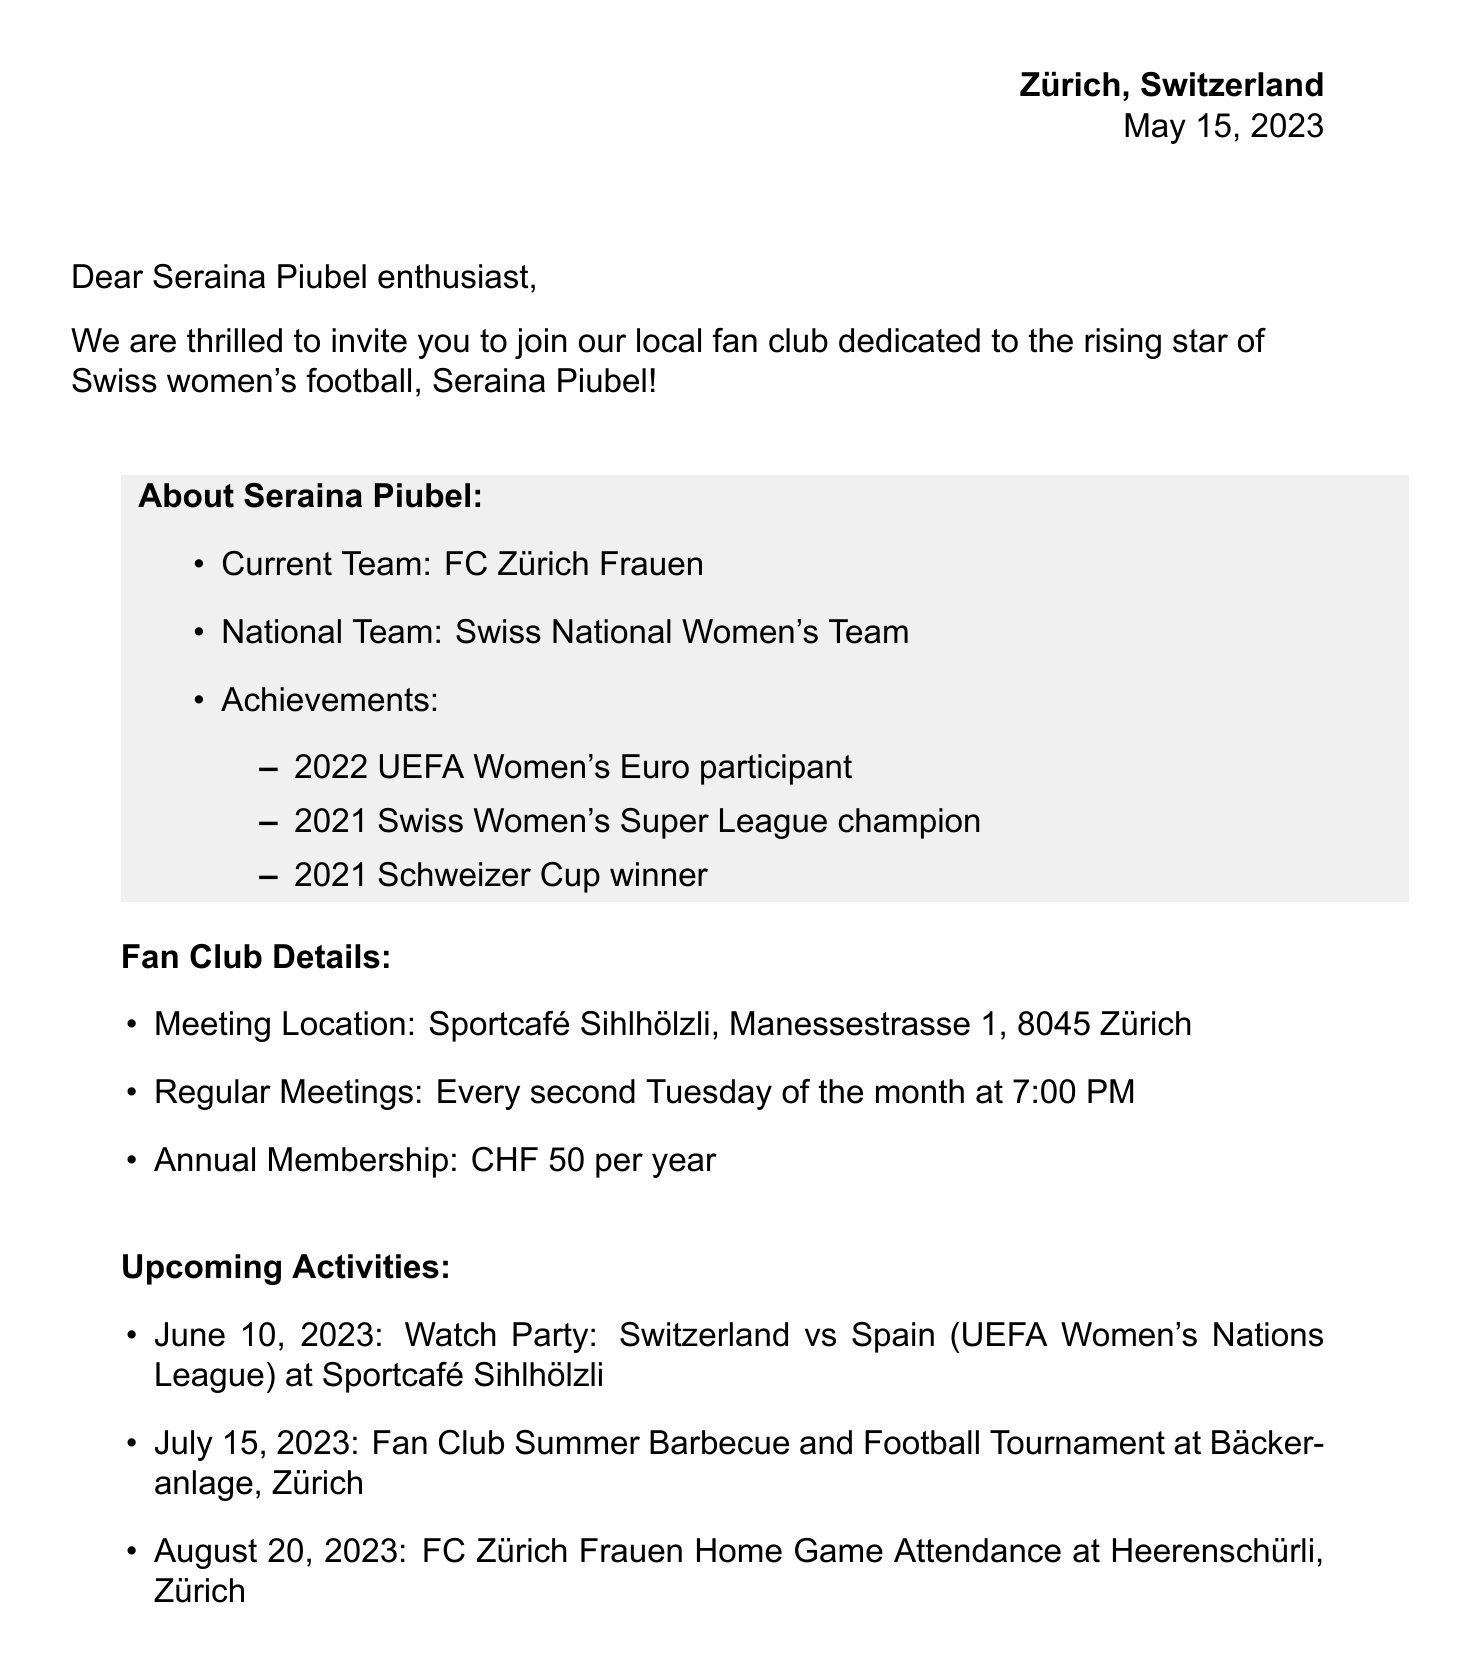What is the name of the fan club? The name of the fan club is explicitly stated in the letter header.
Answer: Swiss Soccer Stars: Seraina Piubel Fan Club When was the invitation letter dated? The date of the letter is mentioned in the letter header.
Answer: May 15, 2023 What is the location of the regular meetings? The meeting location is specified in the fan club details section.
Answer: Sportcafé Sihlhölzli, Manessestrasse 1, 8045 Zürich How much is the annual membership fee? The annual membership fee is clearly stated in the fan club details.
Answer: CHF 50 per year What event is scheduled for June 10, 2023? The upcoming activities section lists specific events with dates.
Answer: Watch Party: Switzerland vs Spain (UEFA Women's Nations League) What team does Seraina Piubel currently play for? The current team of Seraina Piubel is mentioned in the about section.
Answer: FC Zürich Frauen What benefits do members receive related to merchandise? The membership benefits section outlines specific advantages concerning merchandise.
Answer: 10% discount on FC Zürich Frauen merchandise Who is the club president? The contact information section provides details of the club president.
Answer: Lena Müller What is the primary purpose of the fan club? The introduction section specifies the intent of the invitation to join the fan club.
Answer: Celebrate the talent and achievements of Seraina Piubel 